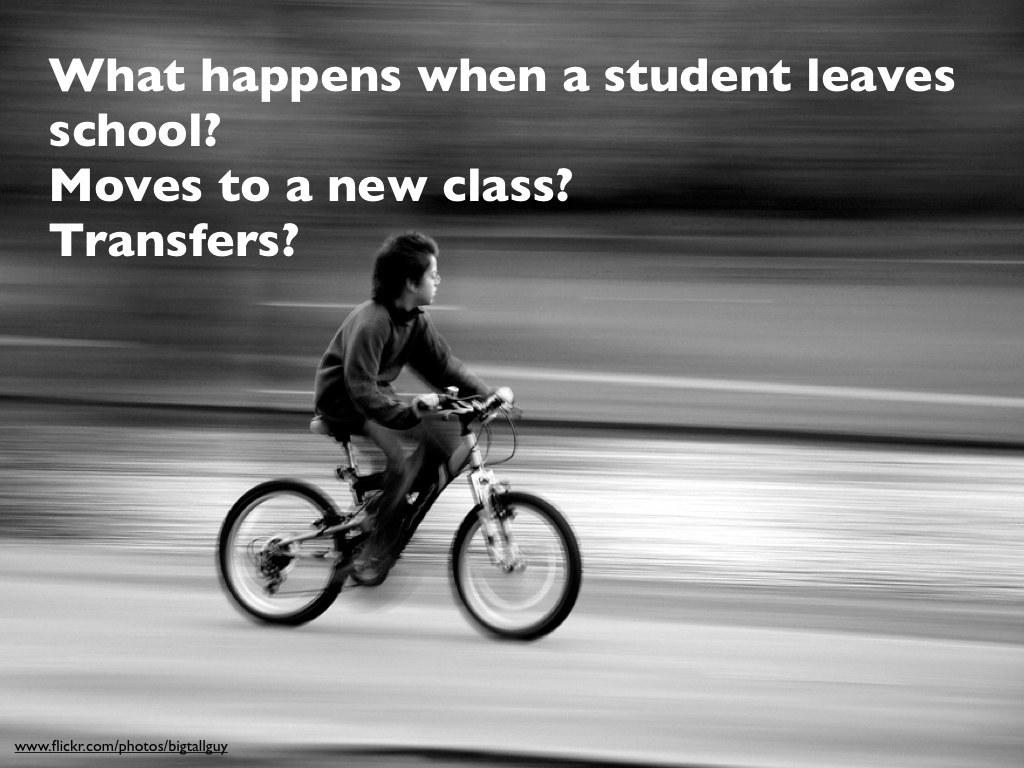Who is the main subject in the image? There is a boy in the image. What is the boy doing in the image? The boy is riding a bicycle. Where is the bicycle located in the image? The bicycle is in the street. What can be observed about the background of the image? The background of the image is dark. What is the cause of the meeting between the boy and the bike in the image? There is no meeting between the boy and the bike in the image; the boy is simply riding the bicycle. 